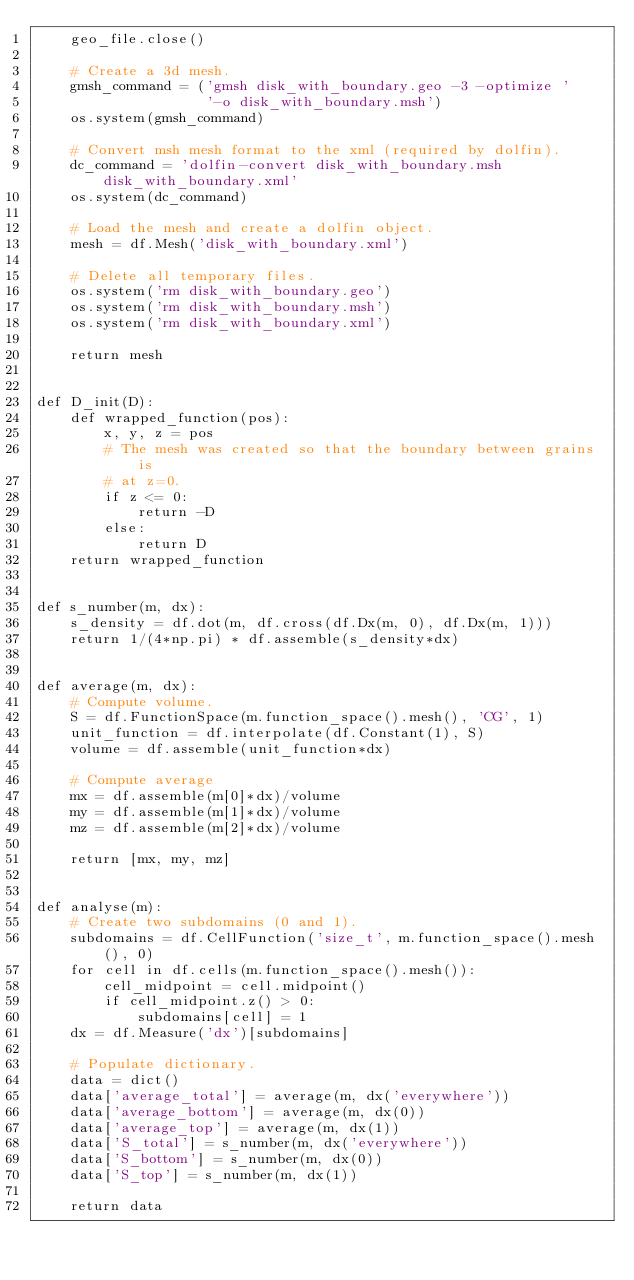<code> <loc_0><loc_0><loc_500><loc_500><_Python_>    geo_file.close()

    # Create a 3d mesh.
    gmsh_command = ('gmsh disk_with_boundary.geo -3 -optimize '
                    '-o disk_with_boundary.msh')
    os.system(gmsh_command)

    # Convert msh mesh format to the xml (required by dolfin).
    dc_command = 'dolfin-convert disk_with_boundary.msh disk_with_boundary.xml'
    os.system(dc_command)

    # Load the mesh and create a dolfin object.
    mesh = df.Mesh('disk_with_boundary.xml')

    # Delete all temporary files.
    os.system('rm disk_with_boundary.geo')
    os.system('rm disk_with_boundary.msh')
    os.system('rm disk_with_boundary.xml')

    return mesh


def D_init(D):
    def wrapped_function(pos):
        x, y, z = pos
        # The mesh was created so that the boundary between grains is
        # at z=0.
        if z <= 0:
            return -D
        else:
            return D
    return wrapped_function


def s_number(m, dx):
    s_density = df.dot(m, df.cross(df.Dx(m, 0), df.Dx(m, 1)))
    return 1/(4*np.pi) * df.assemble(s_density*dx)


def average(m, dx):
    # Compute volume.
    S = df.FunctionSpace(m.function_space().mesh(), 'CG', 1)
    unit_function = df.interpolate(df.Constant(1), S)
    volume = df.assemble(unit_function*dx)

    # Compute average
    mx = df.assemble(m[0]*dx)/volume
    my = df.assemble(m[1]*dx)/volume
    mz = df.assemble(m[2]*dx)/volume

    return [mx, my, mz]


def analyse(m):
    # Create two subdomains (0 and 1).
    subdomains = df.CellFunction('size_t', m.function_space().mesh(), 0)
    for cell in df.cells(m.function_space().mesh()):
        cell_midpoint = cell.midpoint()
        if cell_midpoint.z() > 0:
            subdomains[cell] = 1
    dx = df.Measure('dx')[subdomains]

    # Populate dictionary.
    data = dict()
    data['average_total'] = average(m, dx('everywhere'))
    data['average_bottom'] = average(m, dx(0))
    data['average_top'] = average(m, dx(1))
    data['S_total'] = s_number(m, dx('everywhere'))
    data['S_bottom'] = s_number(m, dx(0))
    data['S_top'] = s_number(m, dx(1))

    return data
</code> 